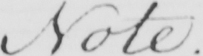Transcribe the text shown in this historical manuscript line. Note . 